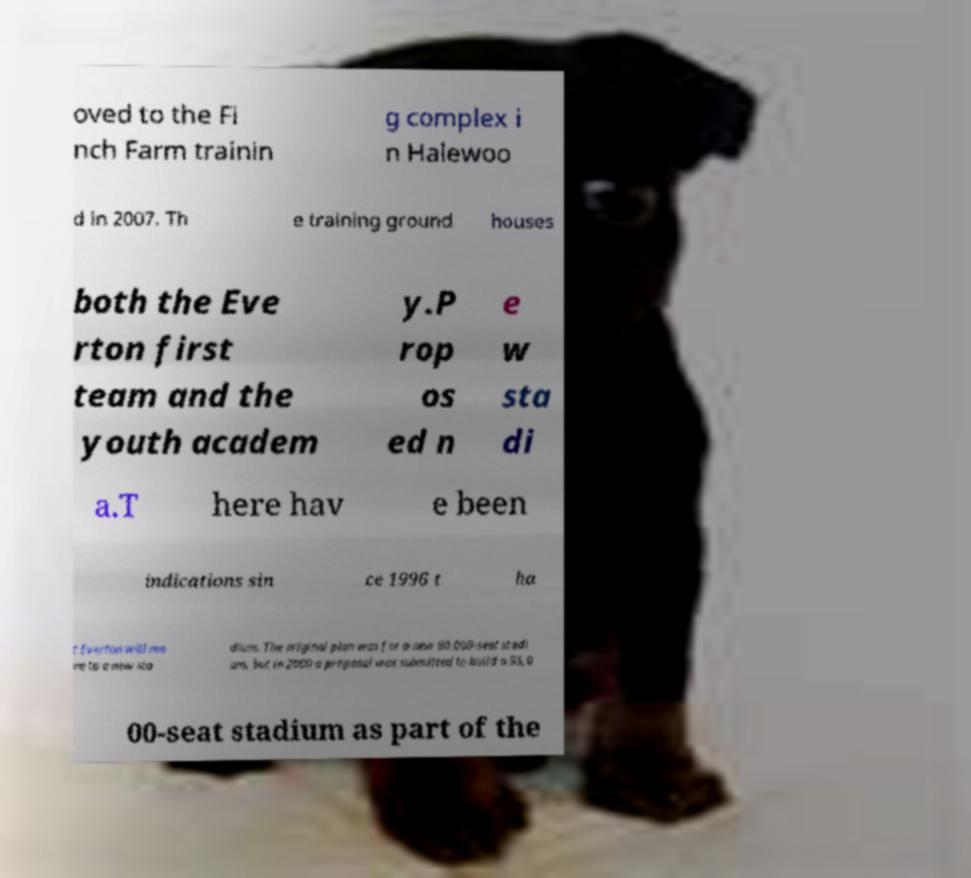Please read and relay the text visible in this image. What does it say? oved to the Fi nch Farm trainin g complex i n Halewoo d in 2007. Th e training ground houses both the Eve rton first team and the youth academ y.P rop os ed n e w sta di a.T here hav e been indications sin ce 1996 t ha t Everton will mo ve to a new sta dium. The original plan was for a new 60,000-seat stadi um, but in 2000 a proposal was submitted to build a 55,0 00-seat stadium as part of the 